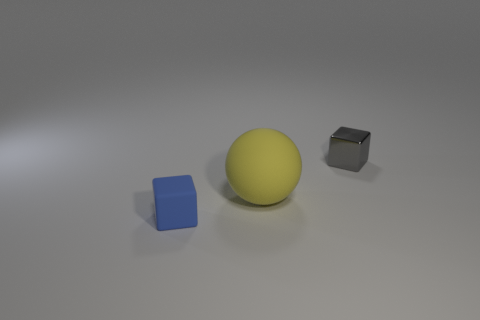What number of small shiny cubes are to the left of the matte object that is right of the rubber object that is in front of the yellow matte thing?
Your answer should be compact. 0. How big is the rubber cube?
Provide a short and direct response. Small. What material is the gray object that is the same size as the blue rubber block?
Offer a terse response. Metal. There is a large matte object; what number of tiny objects are on the left side of it?
Provide a short and direct response. 1. Do the cube that is in front of the rubber sphere and the tiny block that is behind the blue matte cube have the same material?
Your response must be concise. No. There is a rubber object that is on the right side of the cube that is in front of the tiny cube behind the rubber cube; what is its shape?
Offer a terse response. Sphere. What is the shape of the large yellow object?
Offer a very short reply. Sphere. What is the shape of the other blue thing that is the same size as the metal thing?
Offer a very short reply. Cube. There is a small thing that is to the left of the small gray object; is its shape the same as the matte thing behind the tiny blue thing?
Your answer should be very brief. No. What number of objects are small blocks on the right side of the ball or objects that are in front of the tiny gray thing?
Provide a succinct answer. 3. 